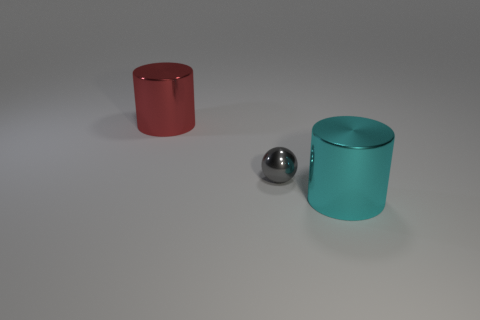Add 2 metal cylinders. How many objects exist? 5 Subtract all cyan balls. Subtract all brown cylinders. How many balls are left? 1 Subtract all spheres. How many objects are left? 2 Add 3 cyan metallic cylinders. How many cyan metallic cylinders are left? 4 Add 2 large blue shiny objects. How many large blue shiny objects exist? 2 Subtract 0 gray cubes. How many objects are left? 3 Subtract all matte things. Subtract all shiny objects. How many objects are left? 0 